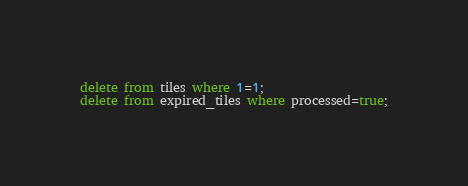<code> <loc_0><loc_0><loc_500><loc_500><_SQL_>delete from tiles where 1=1;
delete from expired_tiles where processed=true;
</code> 